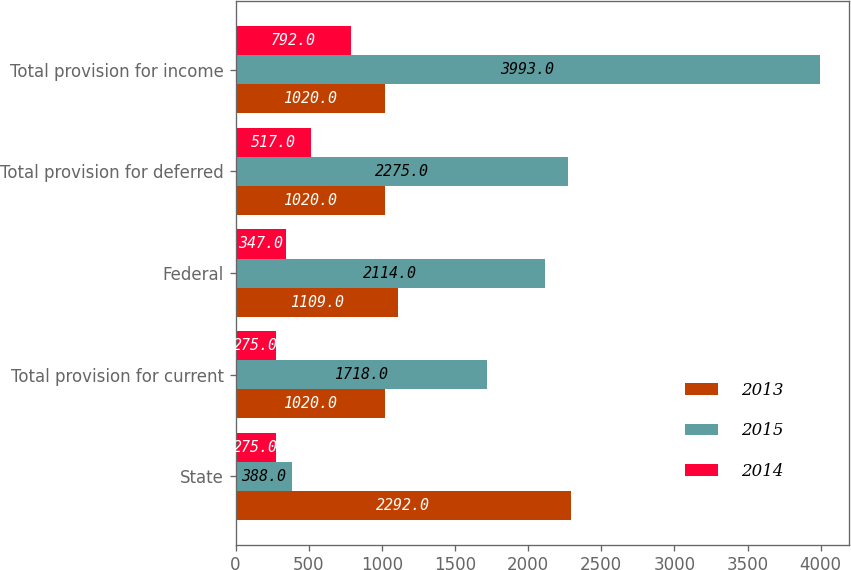<chart> <loc_0><loc_0><loc_500><loc_500><stacked_bar_chart><ecel><fcel>State<fcel>Total provision for current<fcel>Federal<fcel>Total provision for deferred<fcel>Total provision for income<nl><fcel>2013<fcel>2292<fcel>1020<fcel>1109<fcel>1020<fcel>1020<nl><fcel>2015<fcel>388<fcel>1718<fcel>2114<fcel>2275<fcel>3993<nl><fcel>2014<fcel>275<fcel>275<fcel>347<fcel>517<fcel>792<nl></chart> 